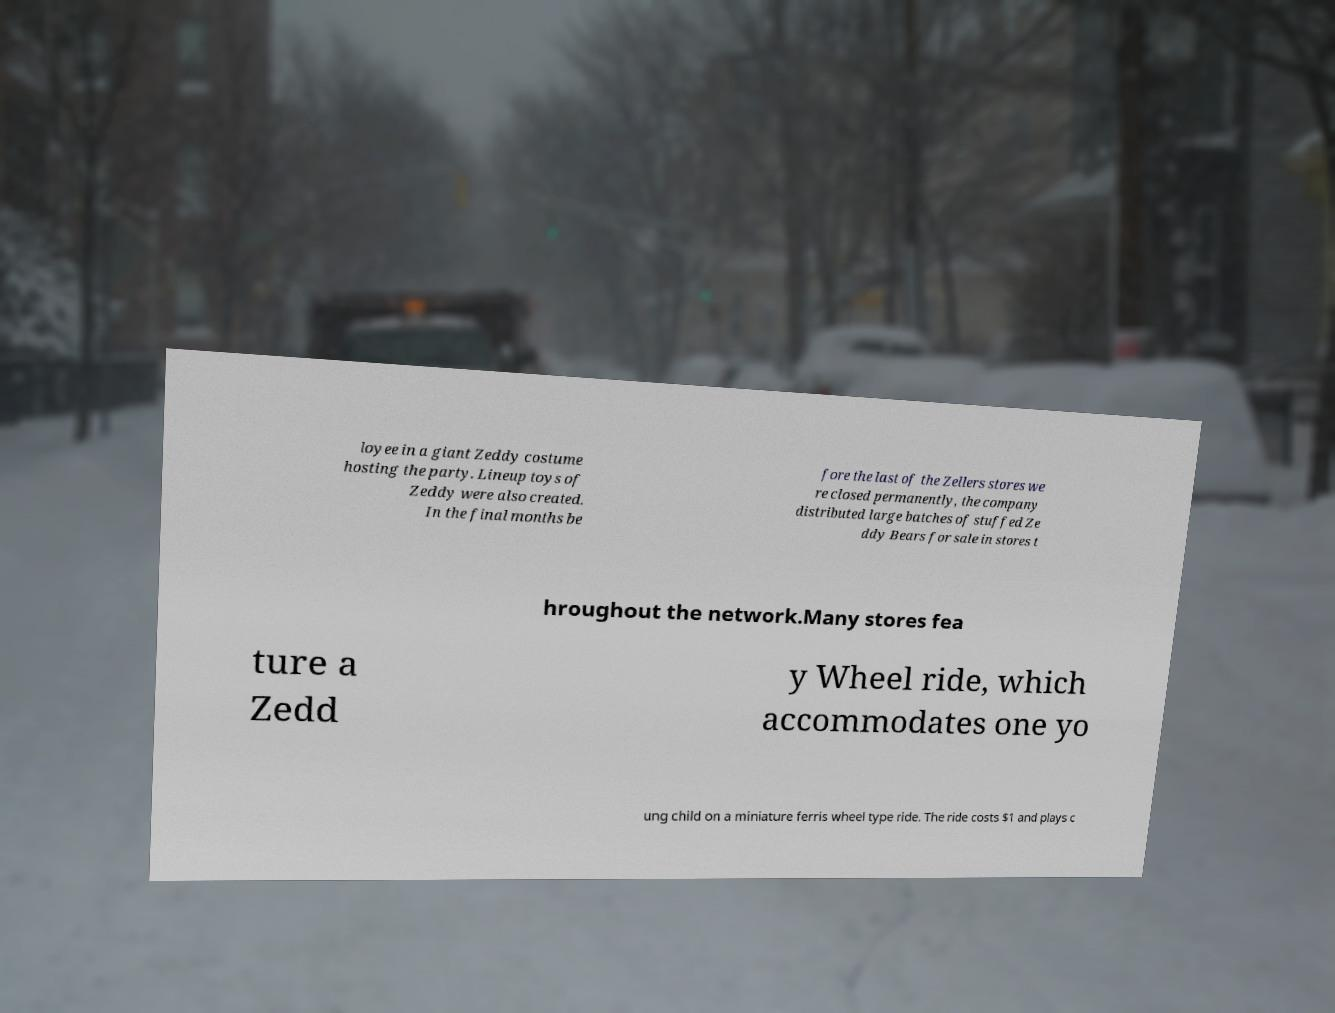For documentation purposes, I need the text within this image transcribed. Could you provide that? loyee in a giant Zeddy costume hosting the party. Lineup toys of Zeddy were also created. In the final months be fore the last of the Zellers stores we re closed permanently, the company distributed large batches of stuffed Ze ddy Bears for sale in stores t hroughout the network.Many stores fea ture a Zedd y Wheel ride, which accommodates one yo ung child on a miniature ferris wheel type ride. The ride costs $1 and plays c 